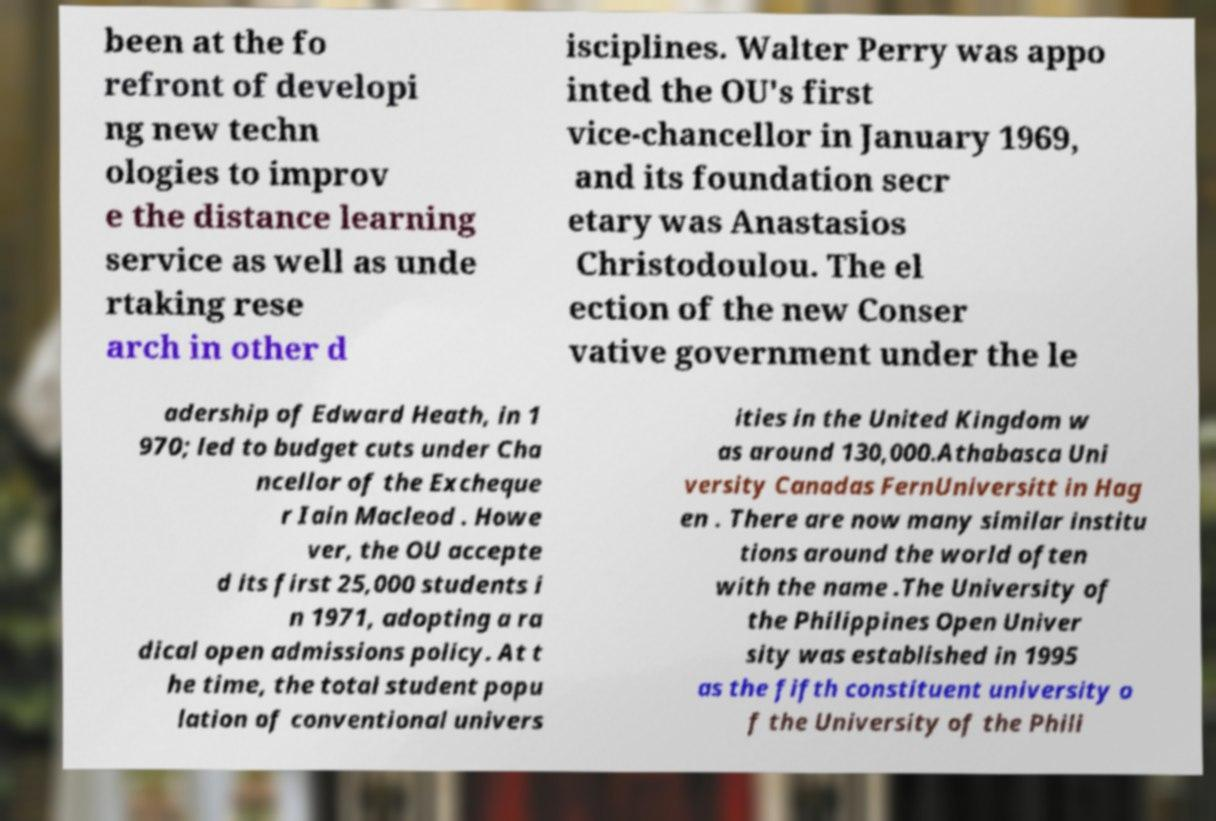Please identify and transcribe the text found in this image. been at the fo refront of developi ng new techn ologies to improv e the distance learning service as well as unde rtaking rese arch in other d isciplines. Walter Perry was appo inted the OU's first vice-chancellor in January 1969, and its foundation secr etary was Anastasios Christodoulou. The el ection of the new Conser vative government under the le adership of Edward Heath, in 1 970; led to budget cuts under Cha ncellor of the Excheque r Iain Macleod . Howe ver, the OU accepte d its first 25,000 students i n 1971, adopting a ra dical open admissions policy. At t he time, the total student popu lation of conventional univers ities in the United Kingdom w as around 130,000.Athabasca Uni versity Canadas FernUniversitt in Hag en . There are now many similar institu tions around the world often with the name .The University of the Philippines Open Univer sity was established in 1995 as the fifth constituent university o f the University of the Phili 